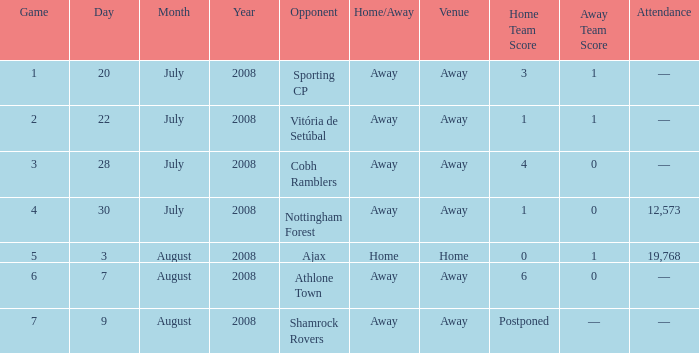Could you help me parse every detail presented in this table? {'header': ['Game', 'Day', 'Month', 'Year', 'Opponent', 'Home/Away', 'Venue', 'Home Team Score', 'Away Team Score', 'Attendance'], 'rows': [['1', '20', 'July', '2008', 'Sporting CP', 'Away', 'Away', '3', '1', '—'], ['2', '22', 'July', '2008', 'Vitória de Setúbal', 'Away', 'Away', '1', '1', '—'], ['3', '28', 'July', '2008', 'Cobh Ramblers', 'Away', 'Away', '4', '0', '—'], ['4', '30', 'July', '2008', 'Nottingham Forest', 'Away', 'Away', '1', '0', '12,573'], ['5', '3', 'August', '2008', 'Ajax', 'Home', 'Home', '0', '1', '19,768'], ['6', '7', 'August', '2008', 'Athlone Town', 'Away', 'Away', '6', '0', '—'], ['7', '9', 'August', '2008', 'Shamrock Rovers', 'Away', 'Away', 'Postponed', '—', '—']]} Where is the location for the third game? Away. 